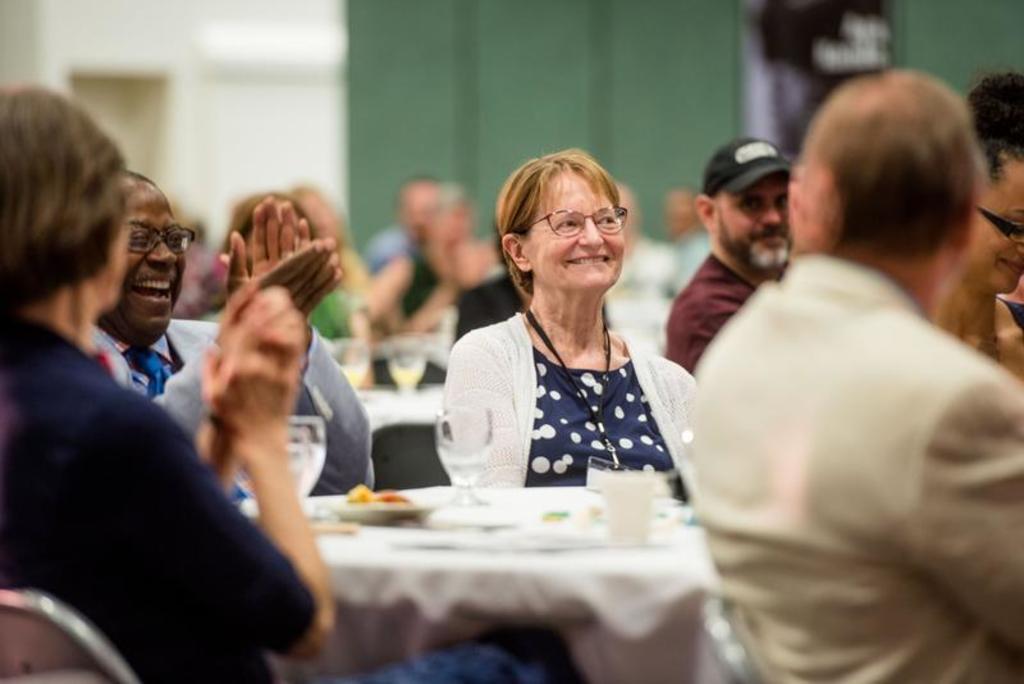How would you summarize this image in a sentence or two? In this image there are group of persons sitting around and applauding someone. 